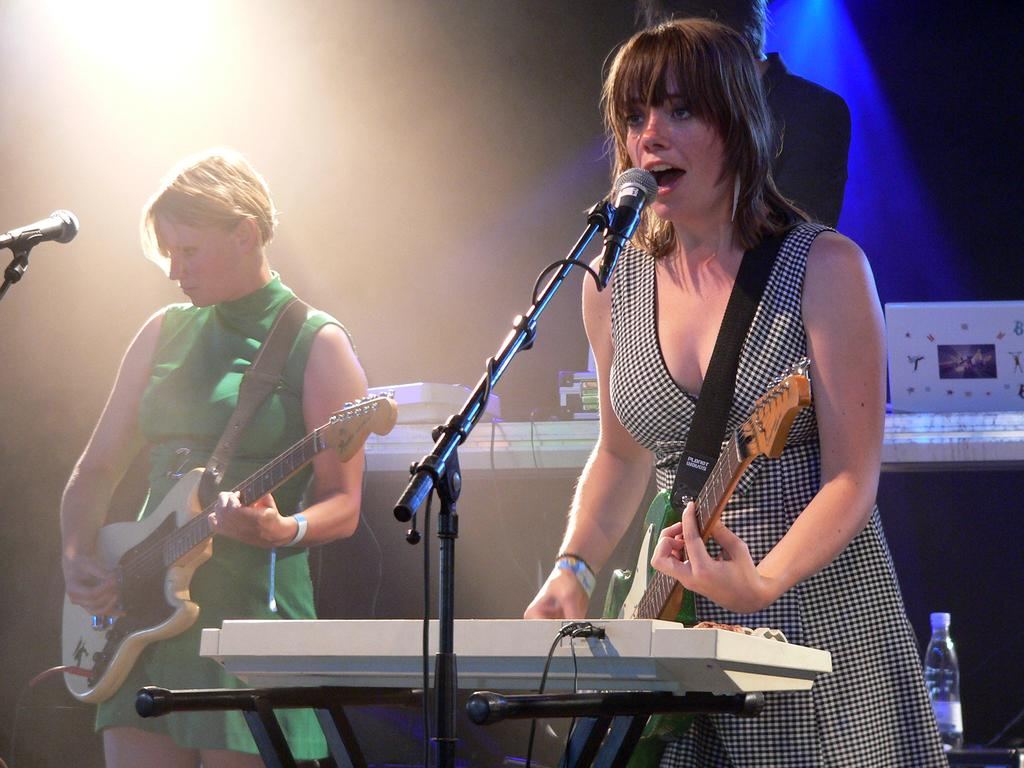What are the people in the image doing? The people in the image are standing and holding guitars. What equipment is present in the image for amplifying sound? There are microphones with stands in the image. What musical instruments can be seen in the image besides guitars? There are pianos in the image. What type of prose is being recited by the family in the image? There is no family or prose present in the image; it features people holding guitars, microphones with stands, and pianos. Can you see a card being used by any of the individuals in the image? There is no card visible in the image. 